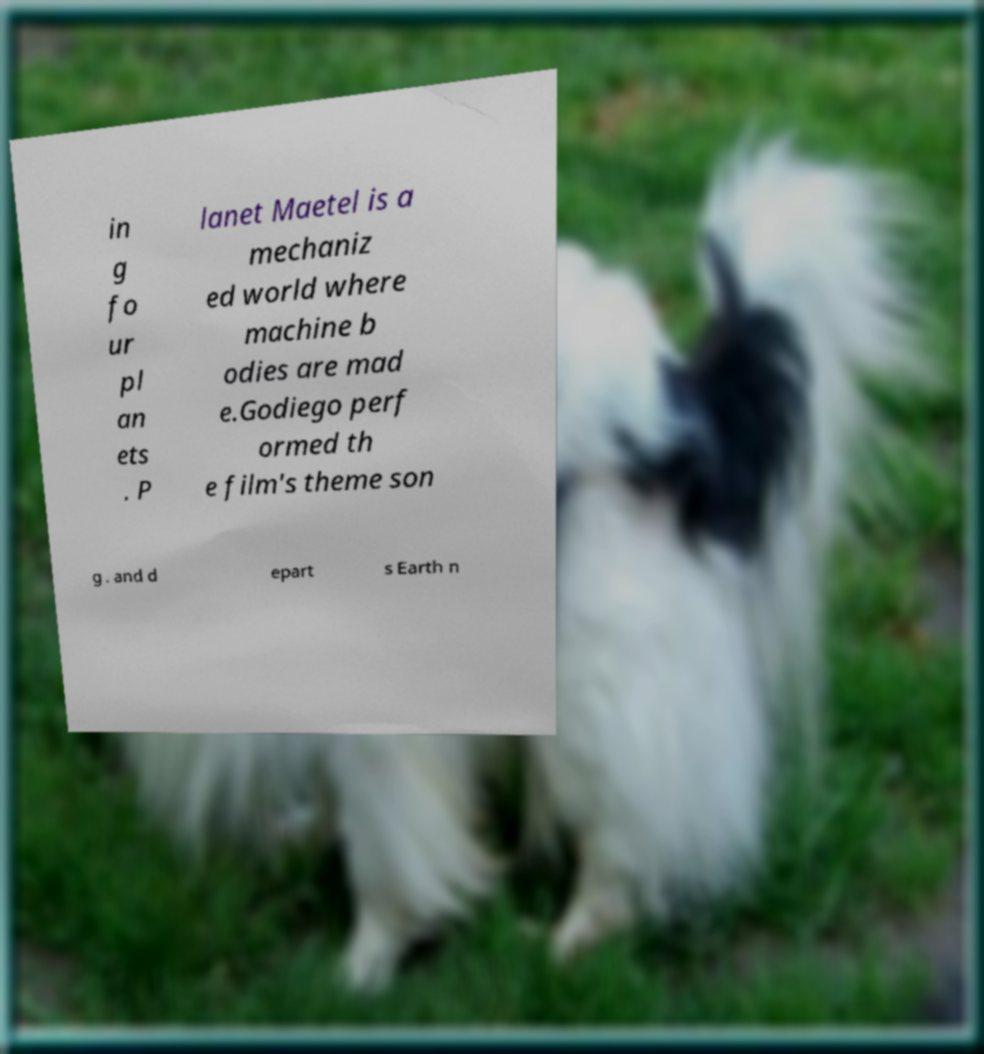I need the written content from this picture converted into text. Can you do that? in g fo ur pl an ets . P lanet Maetel is a mechaniz ed world where machine b odies are mad e.Godiego perf ormed th e film's theme son g . and d epart s Earth n 